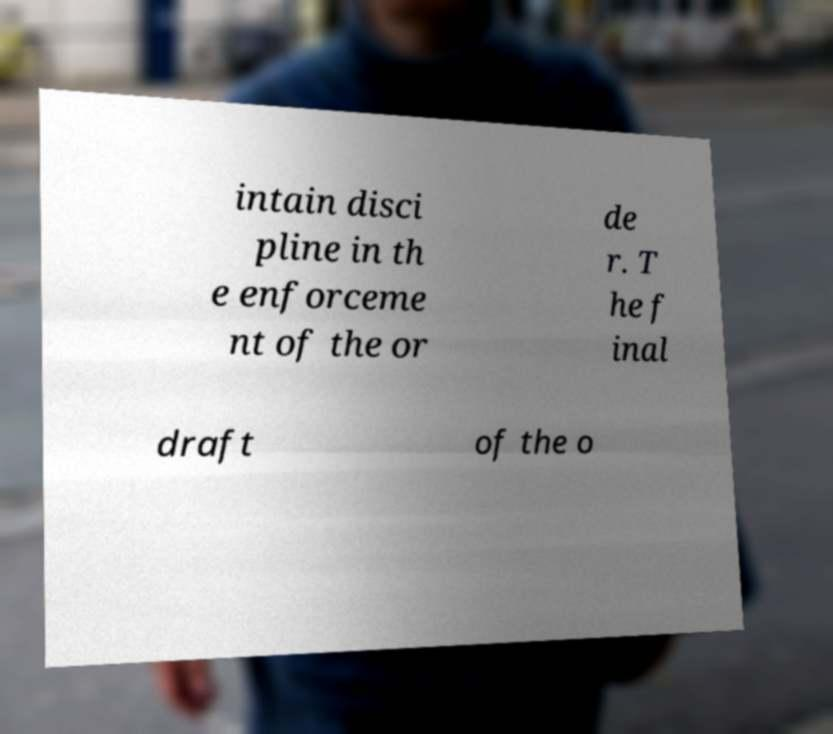Could you extract and type out the text from this image? intain disci pline in th e enforceme nt of the or de r. T he f inal draft of the o 